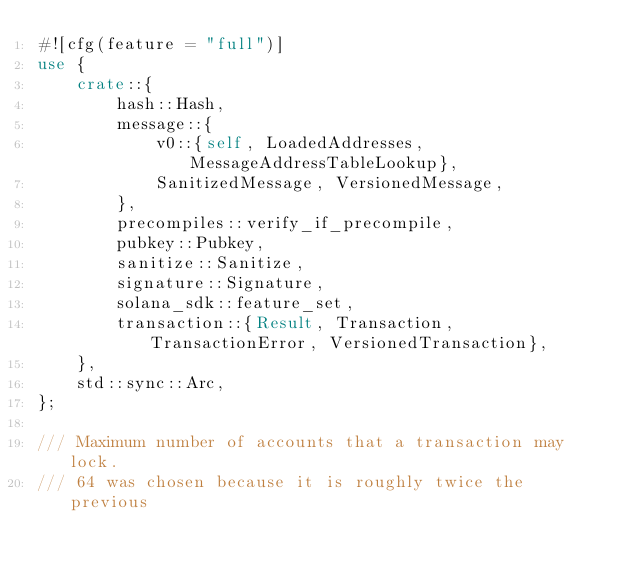Convert code to text. <code><loc_0><loc_0><loc_500><loc_500><_Rust_>#![cfg(feature = "full")]
use {
    crate::{
        hash::Hash,
        message::{
            v0::{self, LoadedAddresses, MessageAddressTableLookup},
            SanitizedMessage, VersionedMessage,
        },
        precompiles::verify_if_precompile,
        pubkey::Pubkey,
        sanitize::Sanitize,
        signature::Signature,
        solana_sdk::feature_set,
        transaction::{Result, Transaction, TransactionError, VersionedTransaction},
    },
    std::sync::Arc,
};

/// Maximum number of accounts that a transaction may lock.
/// 64 was chosen because it is roughly twice the previous</code> 